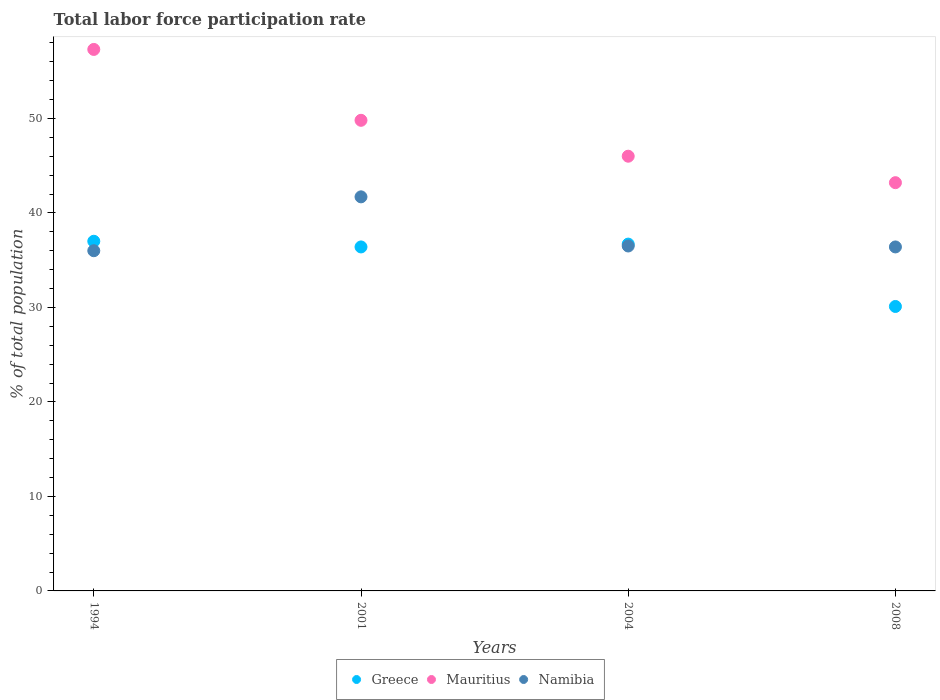What is the total labor force participation rate in Mauritius in 2004?
Your answer should be compact. 46. Across all years, what is the maximum total labor force participation rate in Mauritius?
Give a very brief answer. 57.3. Across all years, what is the minimum total labor force participation rate in Mauritius?
Your answer should be very brief. 43.2. In which year was the total labor force participation rate in Mauritius minimum?
Give a very brief answer. 2008. What is the total total labor force participation rate in Namibia in the graph?
Your answer should be very brief. 150.6. What is the difference between the total labor force participation rate in Greece in 1994 and that in 2004?
Offer a terse response. 0.3. What is the difference between the total labor force participation rate in Mauritius in 2004 and the total labor force participation rate in Greece in 2001?
Your answer should be very brief. 9.6. What is the average total labor force participation rate in Namibia per year?
Provide a short and direct response. 37.65. In the year 2008, what is the difference between the total labor force participation rate in Namibia and total labor force participation rate in Greece?
Provide a short and direct response. 6.3. In how many years, is the total labor force participation rate in Namibia greater than 22 %?
Your answer should be compact. 4. What is the ratio of the total labor force participation rate in Greece in 2004 to that in 2008?
Your response must be concise. 1.22. Is the total labor force participation rate in Namibia in 2001 less than that in 2008?
Your response must be concise. No. Is the difference between the total labor force participation rate in Namibia in 1994 and 2004 greater than the difference between the total labor force participation rate in Greece in 1994 and 2004?
Ensure brevity in your answer.  No. What is the difference between the highest and the second highest total labor force participation rate in Greece?
Keep it short and to the point. 0.3. What is the difference between the highest and the lowest total labor force participation rate in Namibia?
Your answer should be very brief. 5.7. In how many years, is the total labor force participation rate in Mauritius greater than the average total labor force participation rate in Mauritius taken over all years?
Give a very brief answer. 2. How many dotlines are there?
Provide a succinct answer. 3. Does the graph contain any zero values?
Your answer should be compact. No. What is the title of the graph?
Offer a terse response. Total labor force participation rate. What is the label or title of the Y-axis?
Give a very brief answer. % of total population. What is the % of total population of Mauritius in 1994?
Your answer should be compact. 57.3. What is the % of total population of Greece in 2001?
Your answer should be very brief. 36.4. What is the % of total population in Mauritius in 2001?
Offer a terse response. 49.8. What is the % of total population of Namibia in 2001?
Provide a short and direct response. 41.7. What is the % of total population in Greece in 2004?
Offer a very short reply. 36.7. What is the % of total population of Mauritius in 2004?
Ensure brevity in your answer.  46. What is the % of total population of Namibia in 2004?
Provide a short and direct response. 36.5. What is the % of total population in Greece in 2008?
Your answer should be very brief. 30.1. What is the % of total population in Mauritius in 2008?
Make the answer very short. 43.2. What is the % of total population in Namibia in 2008?
Offer a terse response. 36.4. Across all years, what is the maximum % of total population in Mauritius?
Your response must be concise. 57.3. Across all years, what is the maximum % of total population of Namibia?
Your answer should be compact. 41.7. Across all years, what is the minimum % of total population of Greece?
Offer a very short reply. 30.1. Across all years, what is the minimum % of total population in Mauritius?
Give a very brief answer. 43.2. Across all years, what is the minimum % of total population in Namibia?
Give a very brief answer. 36. What is the total % of total population in Greece in the graph?
Keep it short and to the point. 140.2. What is the total % of total population of Mauritius in the graph?
Provide a short and direct response. 196.3. What is the total % of total population in Namibia in the graph?
Your response must be concise. 150.6. What is the difference between the % of total population in Mauritius in 1994 and that in 2001?
Provide a short and direct response. 7.5. What is the difference between the % of total population in Namibia in 1994 and that in 2004?
Provide a short and direct response. -0.5. What is the difference between the % of total population of Mauritius in 1994 and that in 2008?
Ensure brevity in your answer.  14.1. What is the difference between the % of total population of Greece in 2001 and that in 2004?
Your answer should be very brief. -0.3. What is the difference between the % of total population in Mauritius in 2001 and that in 2004?
Offer a terse response. 3.8. What is the difference between the % of total population in Namibia in 2001 and that in 2008?
Your answer should be compact. 5.3. What is the difference between the % of total population of Greece in 2004 and that in 2008?
Your answer should be very brief. 6.6. What is the difference between the % of total population in Greece in 1994 and the % of total population in Mauritius in 2001?
Give a very brief answer. -12.8. What is the difference between the % of total population of Greece in 1994 and the % of total population of Mauritius in 2004?
Give a very brief answer. -9. What is the difference between the % of total population in Mauritius in 1994 and the % of total population in Namibia in 2004?
Keep it short and to the point. 20.8. What is the difference between the % of total population of Greece in 1994 and the % of total population of Mauritius in 2008?
Provide a short and direct response. -6.2. What is the difference between the % of total population of Mauritius in 1994 and the % of total population of Namibia in 2008?
Offer a terse response. 20.9. What is the difference between the % of total population of Greece in 2001 and the % of total population of Namibia in 2004?
Provide a succinct answer. -0.1. What is the difference between the % of total population of Greece in 2004 and the % of total population of Namibia in 2008?
Your answer should be very brief. 0.3. What is the average % of total population in Greece per year?
Offer a terse response. 35.05. What is the average % of total population of Mauritius per year?
Keep it short and to the point. 49.08. What is the average % of total population of Namibia per year?
Ensure brevity in your answer.  37.65. In the year 1994, what is the difference between the % of total population of Greece and % of total population of Mauritius?
Your response must be concise. -20.3. In the year 1994, what is the difference between the % of total population in Greece and % of total population in Namibia?
Make the answer very short. 1. In the year 1994, what is the difference between the % of total population in Mauritius and % of total population in Namibia?
Provide a short and direct response. 21.3. In the year 2001, what is the difference between the % of total population in Greece and % of total population in Mauritius?
Ensure brevity in your answer.  -13.4. In the year 2001, what is the difference between the % of total population of Mauritius and % of total population of Namibia?
Provide a succinct answer. 8.1. What is the ratio of the % of total population in Greece in 1994 to that in 2001?
Ensure brevity in your answer.  1.02. What is the ratio of the % of total population in Mauritius in 1994 to that in 2001?
Ensure brevity in your answer.  1.15. What is the ratio of the % of total population of Namibia in 1994 to that in 2001?
Ensure brevity in your answer.  0.86. What is the ratio of the % of total population of Greece in 1994 to that in 2004?
Give a very brief answer. 1.01. What is the ratio of the % of total population of Mauritius in 1994 to that in 2004?
Offer a terse response. 1.25. What is the ratio of the % of total population in Namibia in 1994 to that in 2004?
Give a very brief answer. 0.99. What is the ratio of the % of total population in Greece in 1994 to that in 2008?
Ensure brevity in your answer.  1.23. What is the ratio of the % of total population in Mauritius in 1994 to that in 2008?
Offer a very short reply. 1.33. What is the ratio of the % of total population in Mauritius in 2001 to that in 2004?
Ensure brevity in your answer.  1.08. What is the ratio of the % of total population in Namibia in 2001 to that in 2004?
Give a very brief answer. 1.14. What is the ratio of the % of total population of Greece in 2001 to that in 2008?
Make the answer very short. 1.21. What is the ratio of the % of total population in Mauritius in 2001 to that in 2008?
Provide a short and direct response. 1.15. What is the ratio of the % of total population of Namibia in 2001 to that in 2008?
Offer a very short reply. 1.15. What is the ratio of the % of total population of Greece in 2004 to that in 2008?
Provide a short and direct response. 1.22. What is the ratio of the % of total population in Mauritius in 2004 to that in 2008?
Give a very brief answer. 1.06. What is the ratio of the % of total population of Namibia in 2004 to that in 2008?
Keep it short and to the point. 1. What is the difference between the highest and the second highest % of total population in Mauritius?
Your answer should be very brief. 7.5. What is the difference between the highest and the lowest % of total population in Mauritius?
Provide a short and direct response. 14.1. What is the difference between the highest and the lowest % of total population in Namibia?
Your answer should be compact. 5.7. 